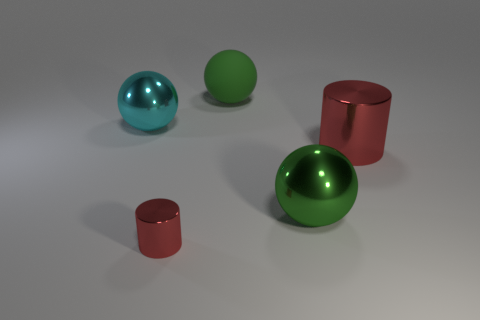The other metal cylinder that is the same color as the small shiny cylinder is what size?
Make the answer very short. Large. There is another metallic thing that is the same color as the tiny metal object; what shape is it?
Offer a very short reply. Cylinder. What is the color of the tiny metal object that is the same shape as the big red metallic object?
Keep it short and to the point. Red. How many large things are cyan metal balls or balls?
Your response must be concise. 3. Does the big red object have the same material as the small thing?
Your response must be concise. Yes. How many matte objects are on the left side of the red metal cylinder that is to the right of the small shiny thing?
Provide a short and direct response. 1. Are there any other cyan objects that have the same shape as the tiny thing?
Your response must be concise. No. There is a large green object behind the cyan object; is its shape the same as the red metal thing right of the tiny red shiny thing?
Provide a succinct answer. No. What shape is the object that is left of the big red metal cylinder and to the right of the rubber thing?
Give a very brief answer. Sphere. Are there any shiny spheres that have the same size as the rubber sphere?
Make the answer very short. Yes. 